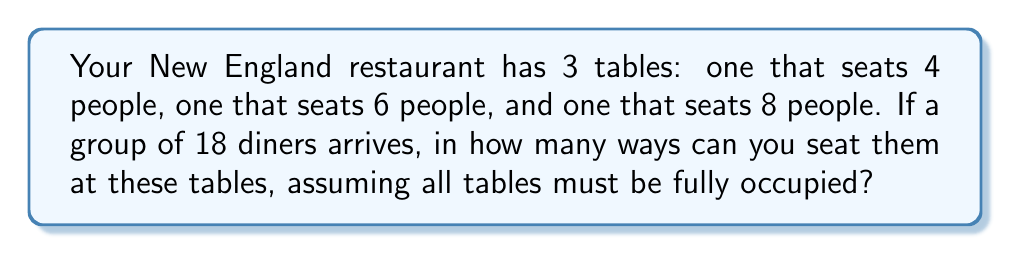Can you answer this question? Let's approach this step-by-step:

1) First, we need to distribute the 18 diners among the three tables. We can use the multiplication principle of counting.

2) For the 4-person table, we need to choose 4 people out of 18. This can be done in $\binom{18}{4}$ ways.

3) After seating 4 people, we have 14 people left. We need to choose 6 of these for the 6-person table. This can be done in $\binom{14}{6}$ ways.

4) The remaining 8 people will automatically be seated at the 8-person table.

5) So far, we have $\binom{18}{4} \cdot \binom{14}{6}$ ways to distribute people to tables.

6) However, for each table, the people can be arranged in different ways:
   - For the 4-person table: 4! ways
   - For the 6-person table: 6! ways
   - For the 8-person table: 8! ways

7) Applying the multiplication principle again, the total number of seating arrangements is:

   $$\binom{18}{4} \cdot \binom{14}{6} \cdot 4! \cdot 6! \cdot 8!$$

8) Let's calculate:
   $\binom{18}{4} = 3060$
   $\binom{14}{6} = 3003$
   $4! = 24$
   $6! = 720$
   $8! = 40320$

9) Multiplying these numbers:

   $3060 \cdot 3003 \cdot 24 \cdot 720 \cdot 40320 = 63,523,355,750,400$
Answer: 63,523,355,750,400 